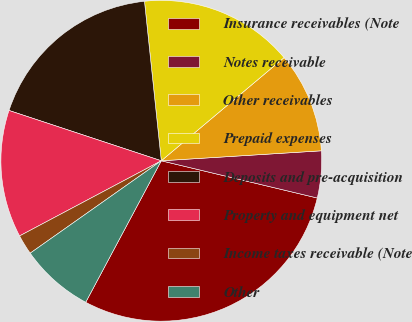Convert chart. <chart><loc_0><loc_0><loc_500><loc_500><pie_chart><fcel>Insurance receivables (Note<fcel>Notes receivable<fcel>Other receivables<fcel>Prepaid expenses<fcel>Deposits and pre-acquisition<fcel>Property and equipment net<fcel>Income taxes receivable (Note<fcel>Other<nl><fcel>29.08%<fcel>4.72%<fcel>10.13%<fcel>15.55%<fcel>18.25%<fcel>12.84%<fcel>2.01%<fcel>7.42%<nl></chart> 